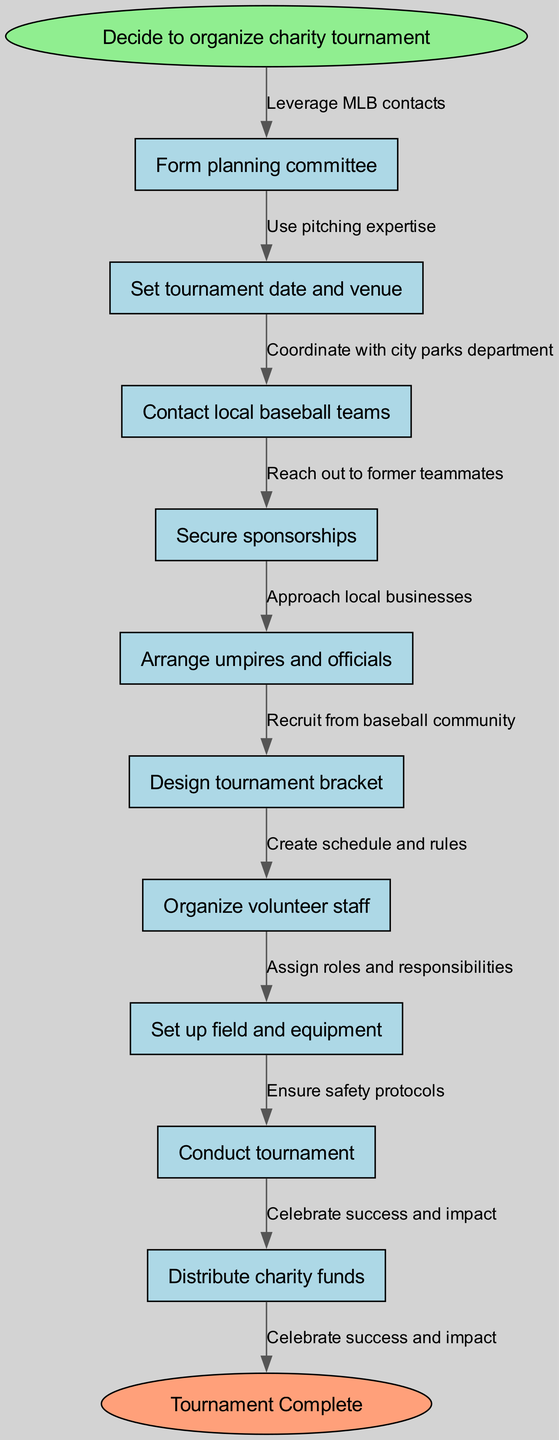What is the first step in the tournament organization process? The diagram starts with the node labeled "Decide to organize charity tournament," indicating that this is the initial step in the flow of the process.
Answer: Decide to organize charity tournament How many nodes are in the diagram? There are ten nodes in total, including the start and end nodes, as counted from the list provided in the diagram data.
Answer: Ten What is the last action taken in the process? The last node before the final node "Tournament Complete" is "Distribute charity funds," which indicates the final action taken in the tournament organization process.
Answer: Distribute charity funds Which node follows "Secure sponsorships"? The direct connection from "Secure sponsorships" leads to the node "Arrange umpires and officials," showing the order in which these steps occur.
Answer: Arrange umpires and officials What is the relationship between "Contact local baseball teams" and "Form planning committee"? The flow shows that "Form planning committee" is the first step, and "Contact local baseball teams" follows directly after it, indicating that contacting teams happens after the committee is formed.
Answer: Directly follows What are the last two actions before "Tournament Complete"? The nodes "Distribute charity funds" and "Celebrate success and impact" are the last two processes, demonstrating that the final steps involve handling funds followed by celebrating the tournament's success.
Answer: Distribute charity funds, Celebrate success and impact How is "Set tournament date and venue" connected to "Organize volunteer staff"? The flow indicates a connection through the intervening steps, showing that both nodes are part of the sequence determined by earlier nodes, thus demonstrating a linear progression through the tournament organization stages.
Answer: Through multiple nodes How many edges connect the nodes in the flow? The diagram contains nine directed edges that connect the ten nodes together, indicating the number of transitions or relationships between the steps in the process.
Answer: Nine Which node represents the action of ensuring safety protocols? The node "Ensure safety protocols" is located before the action "Conduct tournament," pointing to its role in preparing for the event.
Answer: Ensure safety protocols 